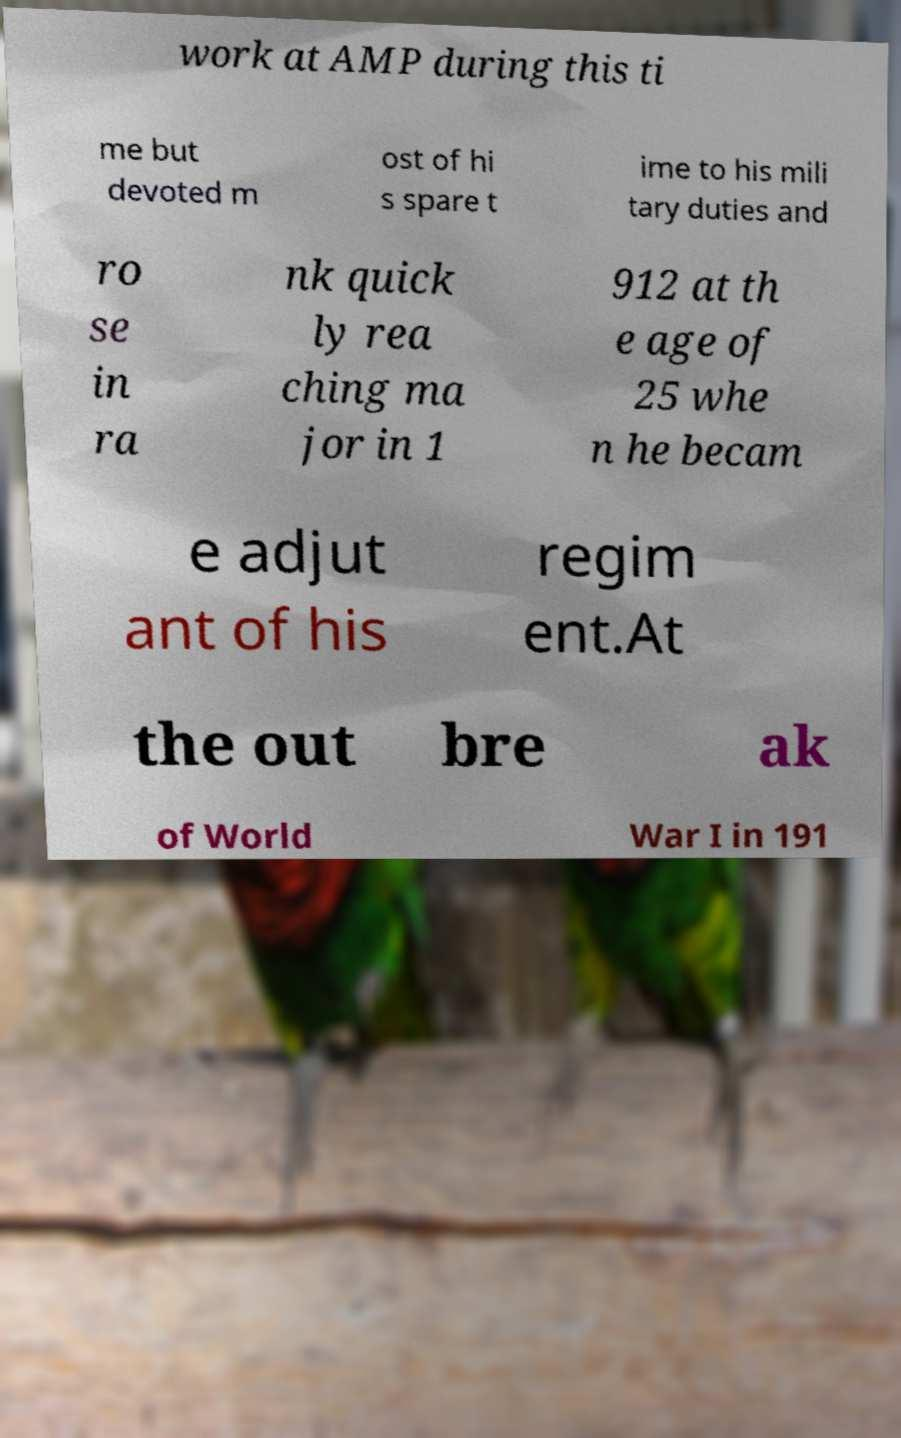Please identify and transcribe the text found in this image. work at AMP during this ti me but devoted m ost of hi s spare t ime to his mili tary duties and ro se in ra nk quick ly rea ching ma jor in 1 912 at th e age of 25 whe n he becam e adjut ant of his regim ent.At the out bre ak of World War I in 191 